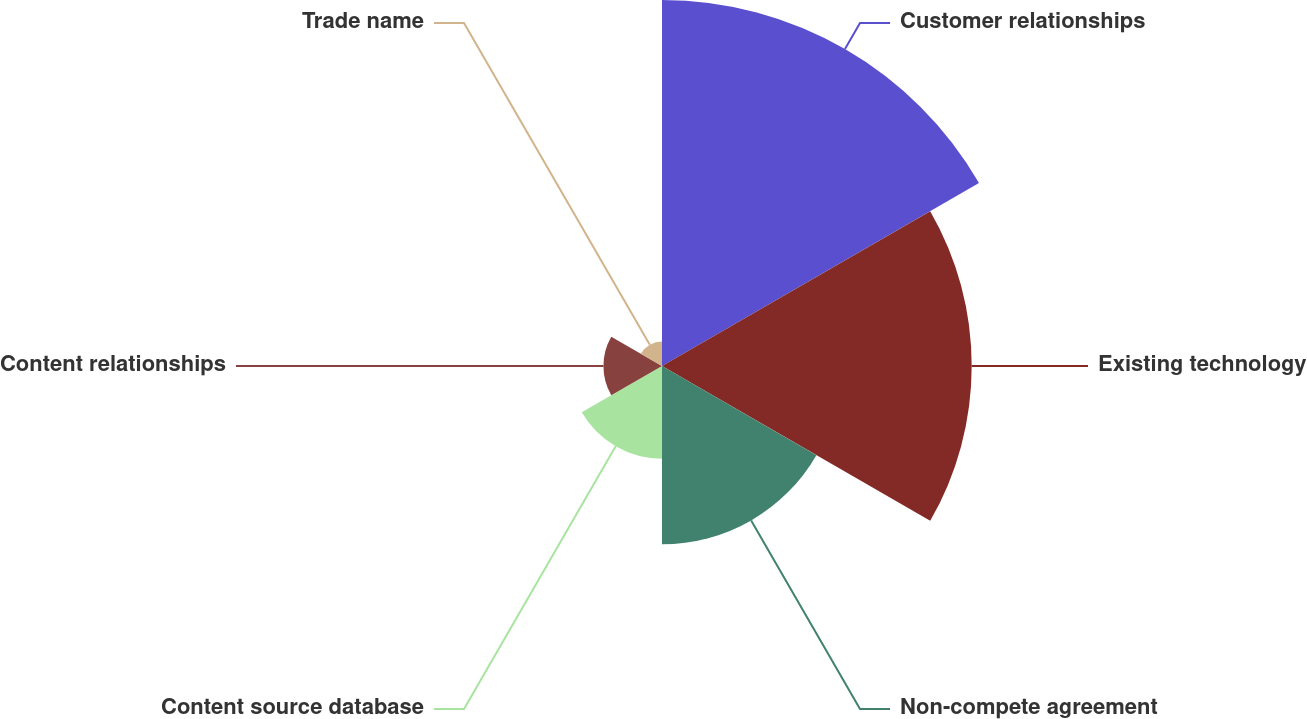<chart> <loc_0><loc_0><loc_500><loc_500><pie_chart><fcel>Customer relationships<fcel>Existing technology<fcel>Non-compete agreement<fcel>Content source database<fcel>Content relationships<fcel>Trade name<nl><fcel>35.55%<fcel>30.08%<fcel>17.32%<fcel>9.0%<fcel>5.69%<fcel>2.37%<nl></chart> 